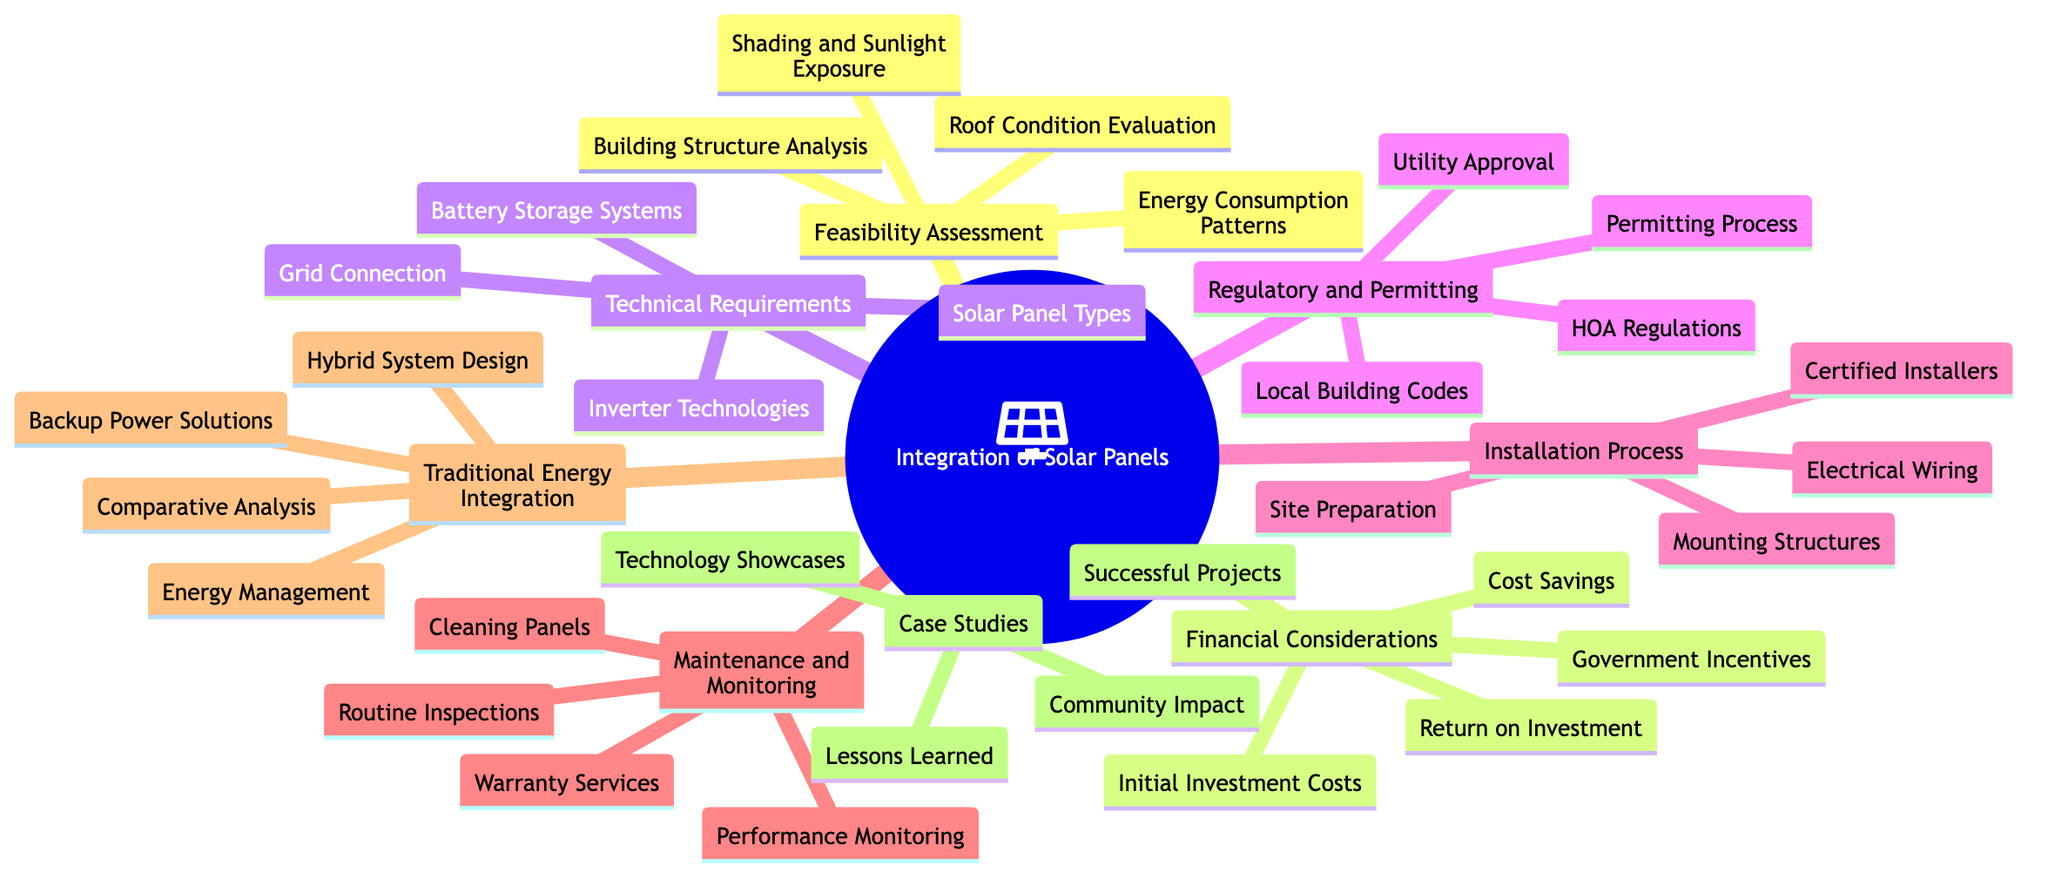What are the four elements of Feasibility Assessment? The diagram lists the elements under the Feasibility Assessment node as Building Structure Analysis, Roof Condition Evaluation, Shading and Sunlight Exposure, and Energy Consumption Patterns. These are directly presented as child nodes of the Feasibility Assessment node.
Answer: Building Structure Analysis, Roof Condition Evaluation, Shading and Sunlight Exposure, Energy Consumption Patterns How many subtopics are there in this concept map? By reviewing the main topic of "Integration of Solar Panels in Existing Residential Buildings," we can count the subtopics listed, which include Feasibility Assessment, Financial Considerations, Technical Requirements, Regulatory and Permitting, Installation Process, Maintenance and Monitoring, Traditional Energy Sources Integration, and Case Studies and Examples. This totals to eight subtopics.
Answer: Eight Which subtopic includes the element "Routine Inspections"? The element "Routine Inspections" is found under the Maintenance and Monitoring subtopic, as indicated by its direct connection to this node on the diagram.
Answer: Maintenance and Monitoring What is the connection between Technical Requirements and Financial Considerations? The connection can be understood as both areas work towards facilitating the integration of solar panels; Technical Requirements specify what technologies are needed while Financial Considerations address the monetary aspects involving these requirements. Although not explicitly shown as connected, they relate contextually in importance to the overall integration process.
Answer: Related contextually Which two elements are part of the Regulatory and Permitting subtopic? The Regulatory and Permitting subtopic contains Local Building Codes and Permitting Process as part of its components, which are outlined explicitly in the diagram.
Answer: Local Building Codes, Permitting Process What does the Traditional Energy Sources Integration subtopic emphasize? The subtopic highlights the integration aspects alongside the traditional energy sources with elements focusing on Hybrid System Design, Backup Power Solutions, Energy Management Systems, and Comparative Analysis with Traditional Energy. Each of these discusses how solar energy can coexist with conventional energy sources.
Answer: Emphasizes hybrid systems and integration with traditional energy sources 